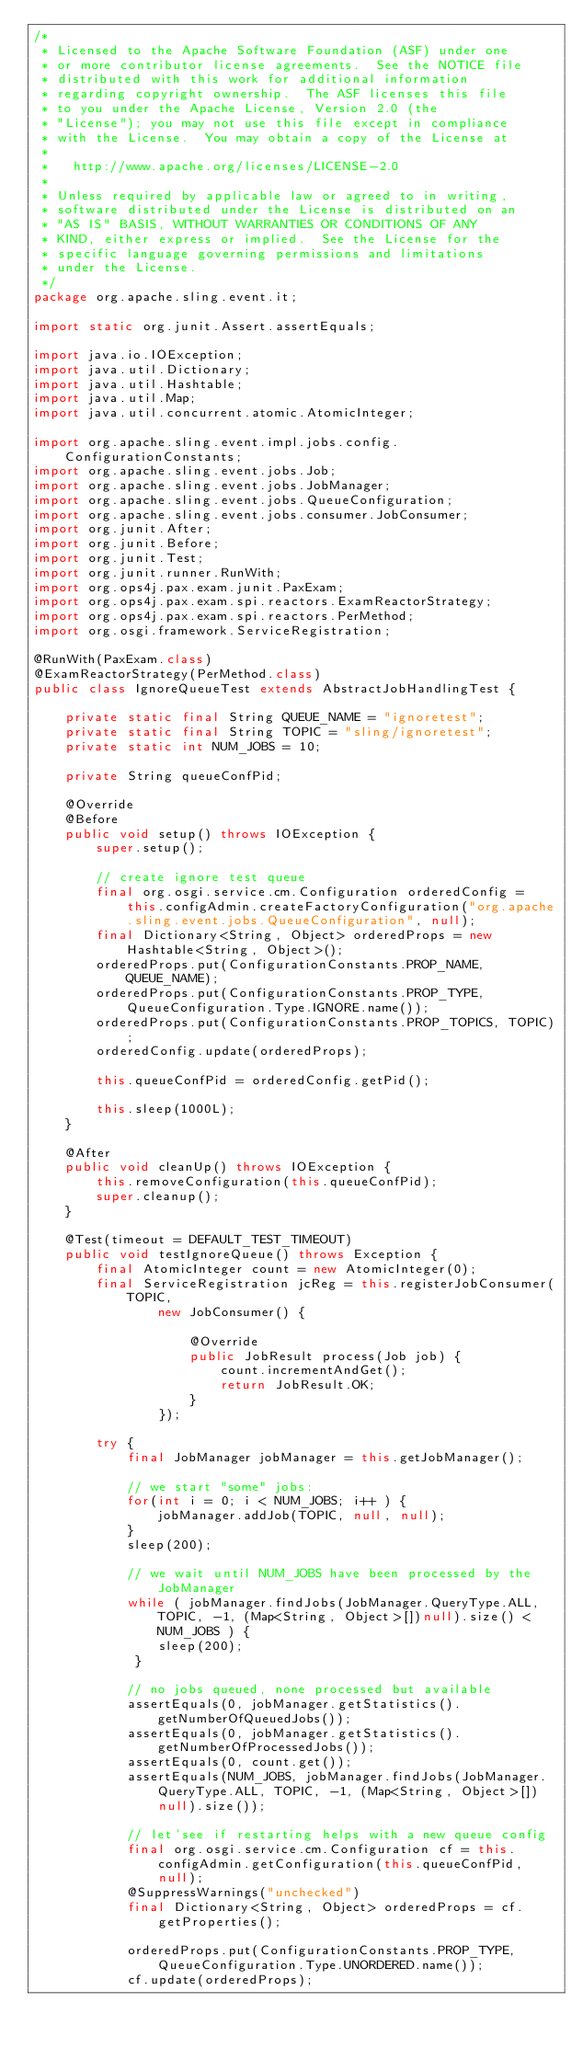<code> <loc_0><loc_0><loc_500><loc_500><_Java_>/*
 * Licensed to the Apache Software Foundation (ASF) under one
 * or more contributor license agreements.  See the NOTICE file
 * distributed with this work for additional information
 * regarding copyright ownership.  The ASF licenses this file
 * to you under the Apache License, Version 2.0 (the
 * "License"); you may not use this file except in compliance
 * with the License.  You may obtain a copy of the License at
 *
 *   http://www.apache.org/licenses/LICENSE-2.0
 *
 * Unless required by applicable law or agreed to in writing,
 * software distributed under the License is distributed on an
 * "AS IS" BASIS, WITHOUT WARRANTIES OR CONDITIONS OF ANY
 * KIND, either express or implied.  See the License for the
 * specific language governing permissions and limitations
 * under the License.
 */
package org.apache.sling.event.it;

import static org.junit.Assert.assertEquals;

import java.io.IOException;
import java.util.Dictionary;
import java.util.Hashtable;
import java.util.Map;
import java.util.concurrent.atomic.AtomicInteger;

import org.apache.sling.event.impl.jobs.config.ConfigurationConstants;
import org.apache.sling.event.jobs.Job;
import org.apache.sling.event.jobs.JobManager;
import org.apache.sling.event.jobs.QueueConfiguration;
import org.apache.sling.event.jobs.consumer.JobConsumer;
import org.junit.After;
import org.junit.Before;
import org.junit.Test;
import org.junit.runner.RunWith;
import org.ops4j.pax.exam.junit.PaxExam;
import org.ops4j.pax.exam.spi.reactors.ExamReactorStrategy;
import org.ops4j.pax.exam.spi.reactors.PerMethod;
import org.osgi.framework.ServiceRegistration;

@RunWith(PaxExam.class)
@ExamReactorStrategy(PerMethod.class)
public class IgnoreQueueTest extends AbstractJobHandlingTest {

    private static final String QUEUE_NAME = "ignoretest";
    private static final String TOPIC = "sling/ignoretest";
    private static int NUM_JOBS = 10;

    private String queueConfPid;

    @Override
    @Before
    public void setup() throws IOException {
        super.setup();

        // create ignore test queue
        final org.osgi.service.cm.Configuration orderedConfig = this.configAdmin.createFactoryConfiguration("org.apache.sling.event.jobs.QueueConfiguration", null);
        final Dictionary<String, Object> orderedProps = new Hashtable<String, Object>();
        orderedProps.put(ConfigurationConstants.PROP_NAME, QUEUE_NAME);
        orderedProps.put(ConfigurationConstants.PROP_TYPE, QueueConfiguration.Type.IGNORE.name());
        orderedProps.put(ConfigurationConstants.PROP_TOPICS, TOPIC);
        orderedConfig.update(orderedProps);

        this.queueConfPid = orderedConfig.getPid();

        this.sleep(1000L);
    }

    @After
    public void cleanUp() throws IOException {
        this.removeConfiguration(this.queueConfPid);
        super.cleanup();
    }

    @Test(timeout = DEFAULT_TEST_TIMEOUT)
    public void testIgnoreQueue() throws Exception {
        final AtomicInteger count = new AtomicInteger(0);
        final ServiceRegistration jcReg = this.registerJobConsumer(TOPIC,
                new JobConsumer() {

                    @Override
                    public JobResult process(Job job) {
                        count.incrementAndGet();
                        return JobResult.OK;
                    }
                });

        try {
            final JobManager jobManager = this.getJobManager();

            // we start "some" jobs:
            for(int i = 0; i < NUM_JOBS; i++ ) {
                jobManager.addJob(TOPIC, null, null);
            }
            sleep(200);

            // we wait until NUM_JOBS have been processed by the JobManager
            while ( jobManager.findJobs(JobManager.QueryType.ALL, TOPIC, -1, (Map<String, Object>[])null).size() < NUM_JOBS ) {
                sleep(200);
             }

            // no jobs queued, none processed but available
            assertEquals(0, jobManager.getStatistics().getNumberOfQueuedJobs());
            assertEquals(0, jobManager.getStatistics().getNumberOfProcessedJobs());
            assertEquals(0, count.get());
            assertEquals(NUM_JOBS, jobManager.findJobs(JobManager.QueryType.ALL, TOPIC, -1, (Map<String, Object>[])null).size());

            // let'see if restarting helps with a new queue config
            final org.osgi.service.cm.Configuration cf = this.configAdmin.getConfiguration(this.queueConfPid, null);
            @SuppressWarnings("unchecked")
            final Dictionary<String, Object> orderedProps = cf.getProperties();

            orderedProps.put(ConfigurationConstants.PROP_TYPE, QueueConfiguration.Type.UNORDERED.name());
            cf.update(orderedProps);
</code> 